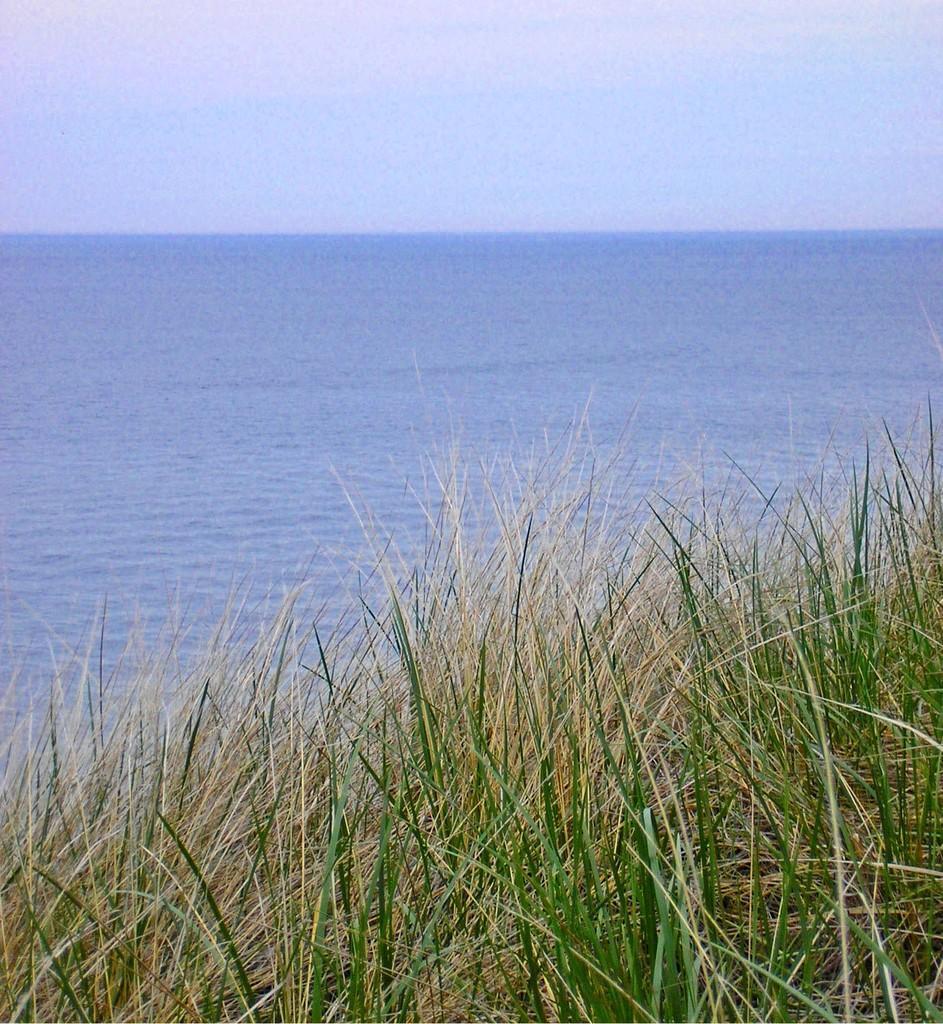Describe this image in one or two sentences. This picture is taken from the outside of the city. In this image, we can see some plants and a grass. In the background, we can see water in a lake. At the top, we can see a sky. 